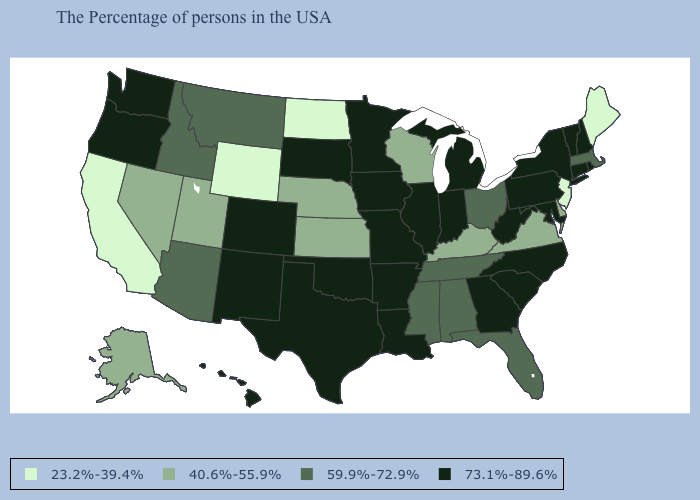How many symbols are there in the legend?
Give a very brief answer. 4. Name the states that have a value in the range 73.1%-89.6%?
Give a very brief answer. Rhode Island, New Hampshire, Vermont, Connecticut, New York, Maryland, Pennsylvania, North Carolina, South Carolina, West Virginia, Georgia, Michigan, Indiana, Illinois, Louisiana, Missouri, Arkansas, Minnesota, Iowa, Oklahoma, Texas, South Dakota, Colorado, New Mexico, Washington, Oregon, Hawaii. Among the states that border Idaho , does Wyoming have the lowest value?
Write a very short answer. Yes. What is the value of Mississippi?
Short answer required. 59.9%-72.9%. Name the states that have a value in the range 40.6%-55.9%?
Keep it brief. Delaware, Virginia, Kentucky, Wisconsin, Kansas, Nebraska, Utah, Nevada, Alaska. Does Florida have the highest value in the USA?
Write a very short answer. No. Does South Carolina have the lowest value in the South?
Give a very brief answer. No. What is the value of Missouri?
Keep it brief. 73.1%-89.6%. What is the value of Hawaii?
Answer briefly. 73.1%-89.6%. Which states have the lowest value in the Northeast?
Short answer required. Maine, New Jersey. What is the lowest value in states that border Pennsylvania?
Concise answer only. 23.2%-39.4%. Does Delaware have the lowest value in the South?
Concise answer only. Yes. How many symbols are there in the legend?
Give a very brief answer. 4. What is the value of Alabama?
Answer briefly. 59.9%-72.9%. What is the value of South Carolina?
Short answer required. 73.1%-89.6%. 